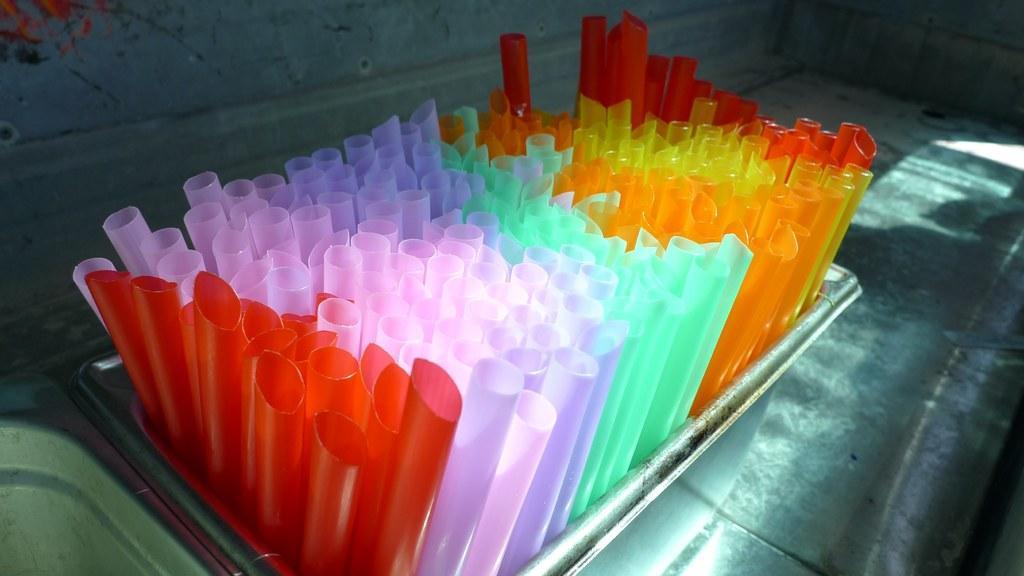In one or two sentences, can you explain what this image depicts? In this image, in the middle, we can see a tray. In the trap, we can see some different colors of straws. In the background, we can see a wall. 